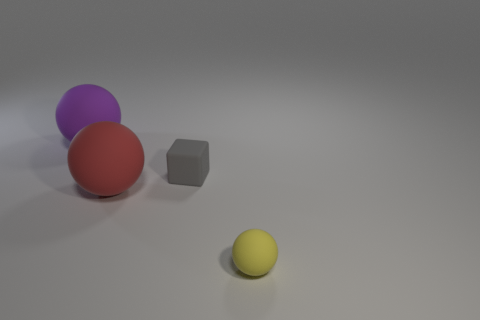Can you tell me the colors of the spheres in the image? Certainly, in the image there are two colored spheres; one is purple, and the other is red. 